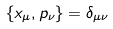Convert formula to latex. <formula><loc_0><loc_0><loc_500><loc_500>\{ x _ { \mu } , p _ { \nu } \} = \delta _ { \mu \nu }</formula> 